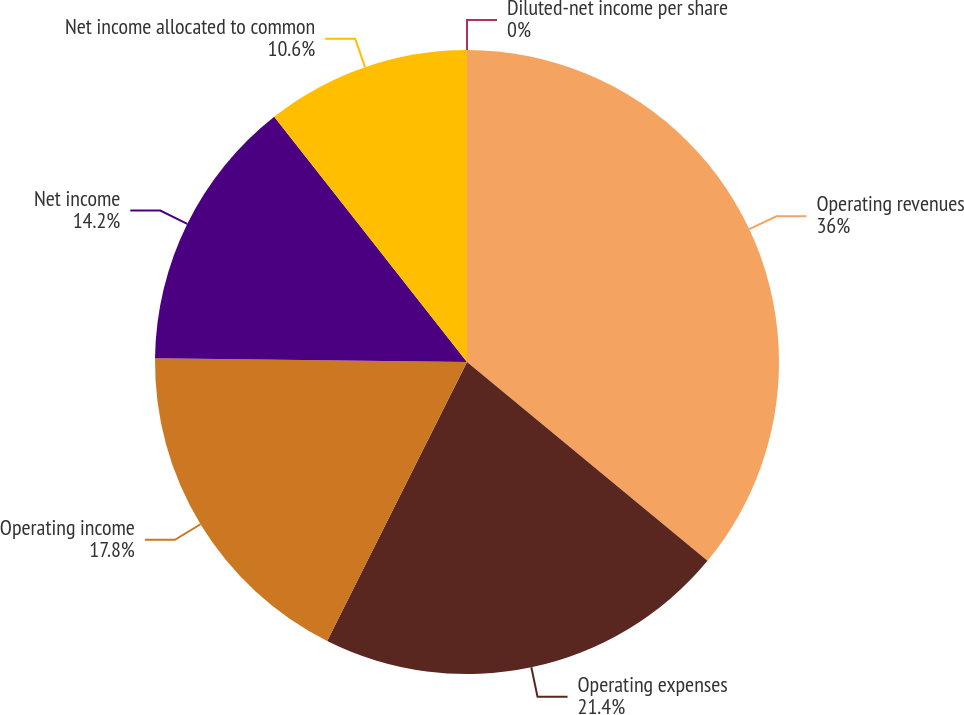Convert chart. <chart><loc_0><loc_0><loc_500><loc_500><pie_chart><fcel>Operating revenues<fcel>Operating expenses<fcel>Operating income<fcel>Net income<fcel>Net income allocated to common<fcel>Diluted-net income per share<nl><fcel>35.99%<fcel>21.4%<fcel>17.8%<fcel>14.2%<fcel>10.6%<fcel>0.0%<nl></chart> 